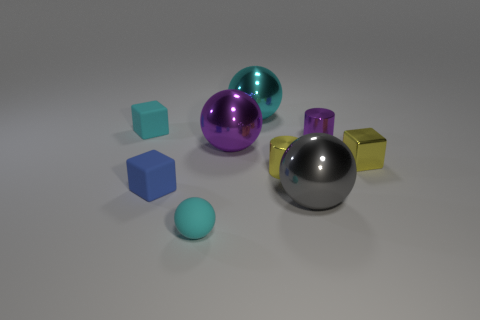Does the matte thing in front of the large gray metallic ball have the same shape as the big gray thing?
Your answer should be compact. Yes. What number of large objects are either cyan matte spheres or yellow metallic things?
Offer a terse response. 0. Is the number of matte cubes that are left of the purple metallic cylinder the same as the number of cyan shiny spheres left of the large cyan sphere?
Give a very brief answer. No. What number of other things are there of the same color as the small matte sphere?
Ensure brevity in your answer.  2. Do the small rubber sphere and the big shiny ball behind the small cyan rubber block have the same color?
Your answer should be compact. Yes. What number of yellow things are big objects or metallic objects?
Provide a succinct answer. 2. Are there an equal number of tiny cyan rubber blocks behind the cyan metal sphere and big things?
Your answer should be very brief. No. What is the color of the other small rubber object that is the same shape as the small blue rubber thing?
Ensure brevity in your answer.  Cyan. What number of blue matte things have the same shape as the big gray metallic thing?
Give a very brief answer. 0. There is a tiny thing that is the same color as the tiny sphere; what is it made of?
Offer a terse response. Rubber. 